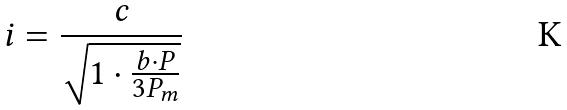<formula> <loc_0><loc_0><loc_500><loc_500>i = \frac { c } { \sqrt { 1 \cdot \frac { b \cdot P } { 3 P _ { m } } } }</formula> 